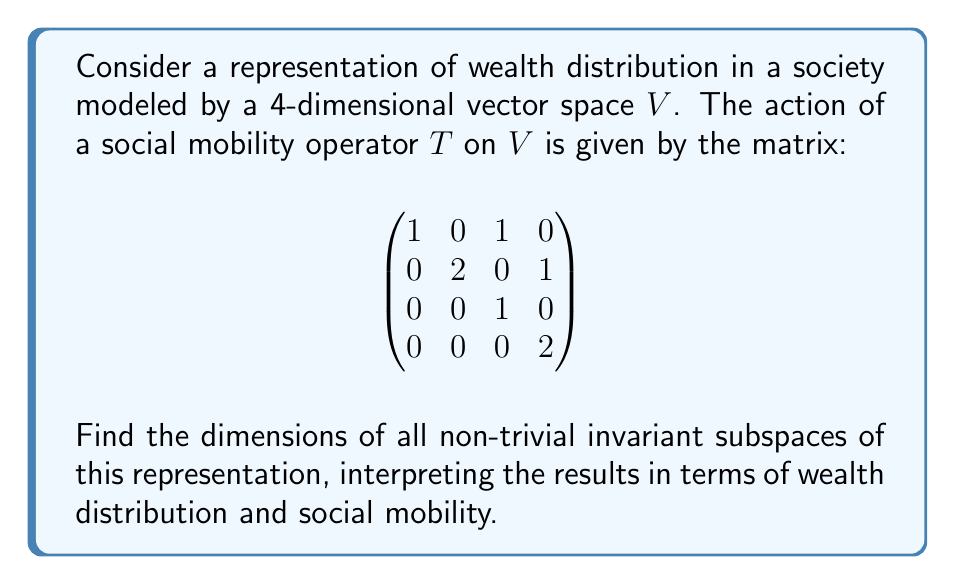Can you solve this math problem? 1) First, we need to find the eigenvalues of $T$. The characteristic polynomial is:

   $$\det(T - \lambda I) = (1-\lambda)^2(2-\lambda)^2 = 0$$

   So the eigenvalues are $\lambda_1 = 1$ (multiplicity 2) and $\lambda_2 = 2$ (multiplicity 2).

2) For $\lambda_1 = 1$, we solve $(T-I)v = 0$:

   $$\begin{pmatrix}
   0 & 0 & 1 & 0 \\
   0 & 1 & 0 & 1 \\
   0 & 0 & 0 & 0 \\
   0 & 0 & 0 & 1
   \end{pmatrix} \begin{pmatrix} v_1 \\ v_2 \\ v_3 \\ v_4 \end{pmatrix} = \begin{pmatrix} 0 \\ 0 \\ 0 \\ 0 \end{pmatrix}$$

   This gives us the eigenspace $E_1 = \text{span}\{(1,0,0,0), (0,0,1,0)\}$.

3) For $\lambda_2 = 2$, we solve $(T-2I)v = 0$:

   $$\begin{pmatrix}
   -1 & 0 & 1 & 0 \\
   0 & 0 & 0 & 1 \\
   0 & 0 & -1 & 0 \\
   0 & 0 & 0 & 0
   \end{pmatrix} \begin{pmatrix} v_1 \\ v_2 \\ v_3 \\ v_4 \end{pmatrix} = \begin{pmatrix} 0 \\ 0 \\ 0 \\ 0 \end{pmatrix}$$

   This gives us the eigenspace $E_2 = \text{span}\{(1,0,1,0), (0,1,0,0)\}$.

4) The non-trivial invariant subspaces are:
   - $E_1$ (dimension 2)
   - $E_2$ (dimension 2)
   - $E_1 \oplus E_2 = V$ (dimension 4)

5) Interpretation:
   - $E_1$ represents a subspace where wealth distribution remains unchanged under $T$.
   - $E_2$ represents a subspace where wealth doubles under $T$.
   - The full space $V$ combines both static and growing wealth distributions.

This representation suggests a society with both stagnant and expanding wealth sectors, reflecting potential inequalities in social mobility.
Answer: Dimensions of non-trivial invariant subspaces: 2, 2, 4 